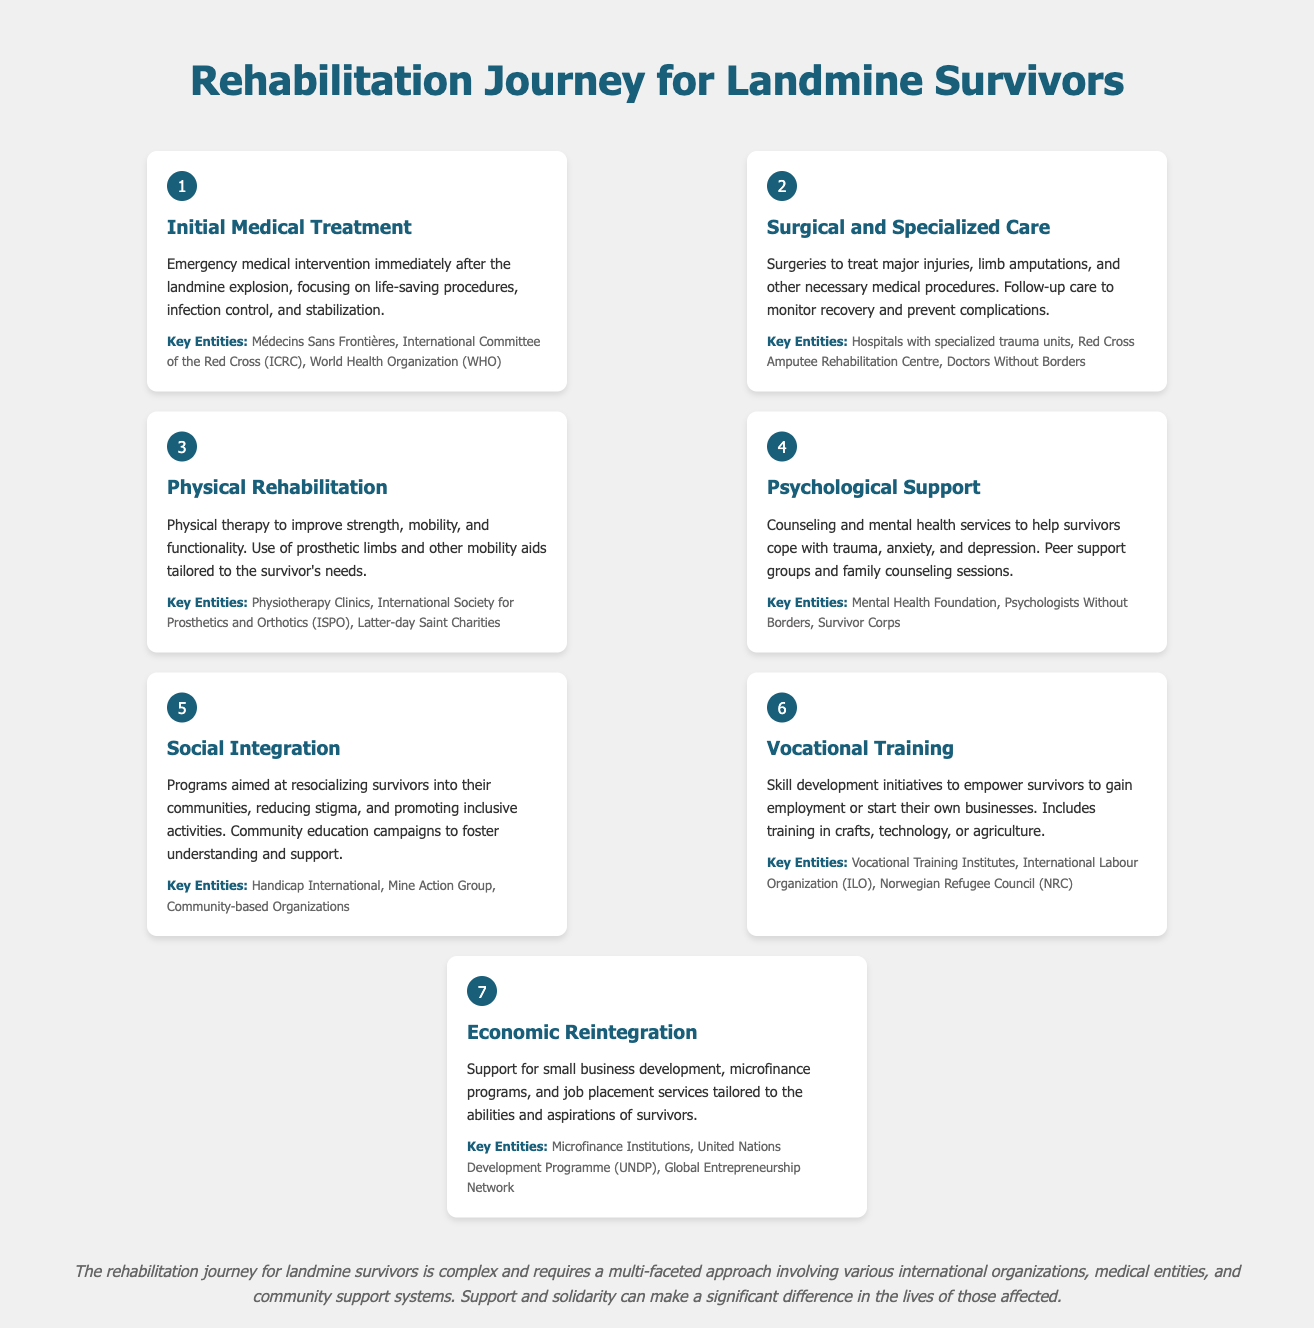what is the first step in the rehabilitation journey? The first step is to provide emergency medical intervention focusing on life-saving procedures, infection control, and stabilization.
Answer: Initial Medical Treatment how many key entities are listed in the Physical Rehabilitation step? The Physical Rehabilitation step lists three key entities involved in providing rehabilitation services.
Answer: 3 what type of support is offered in the Psychological Support step? The Psychological Support step offers counseling and mental health services as well as peer support groups.
Answer: Counseling and mental health services which organizations are involved in the Social Integration process? The Social Integration step mentions several organizations contributing to community education and support aimed at reducing stigma.
Answer: Handicap International, Mine Action Group, Community-based Organizations what is the purpose of Vocational Training in the rehabilitation process? The purpose of Vocational Training is to empower survivors to gain employment or start their own businesses through skill development.
Answer: Empowerment through skill development what is the seventh step in the rehabilitation journey? The seventh step is focused on reintegrating survivors into the economy through business support and job placement.
Answer: Economic Reintegration which organization is indicated for job placement services? The seventh step mentions an international organization that provides support tailored to the abilities of survivors.
Answer: United Nations Development Programme (UNDP) how many steps are there in the rehabilitation journey for landmine survivors? The document outlines the entire process of rehabilitation through a total of seven steps.
Answer: 7 